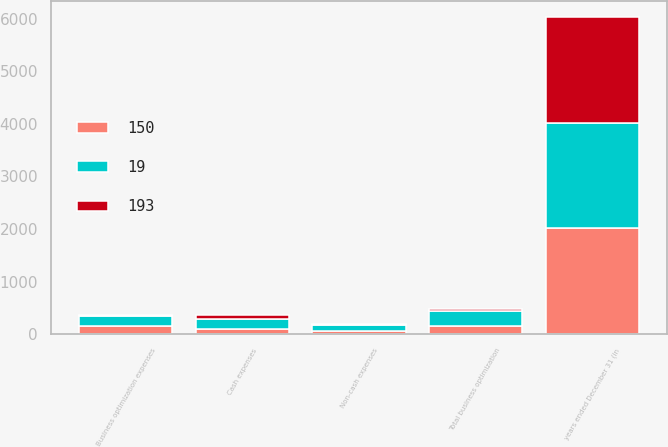Convert chart. <chart><loc_0><loc_0><loc_500><loc_500><stacked_bar_chart><ecel><fcel>years ended December 31 (in<fcel>Cash expenses<fcel>Non-cash expenses<fcel>Total business optimization<fcel>Business optimization expenses<nl><fcel>193<fcel>2014<fcel>87<fcel>4<fcel>27<fcel>19<nl><fcel>19<fcel>2013<fcel>182<fcel>132<fcel>294<fcel>193<nl><fcel>150<fcel>2012<fcel>98<fcel>52<fcel>150<fcel>150<nl></chart> 